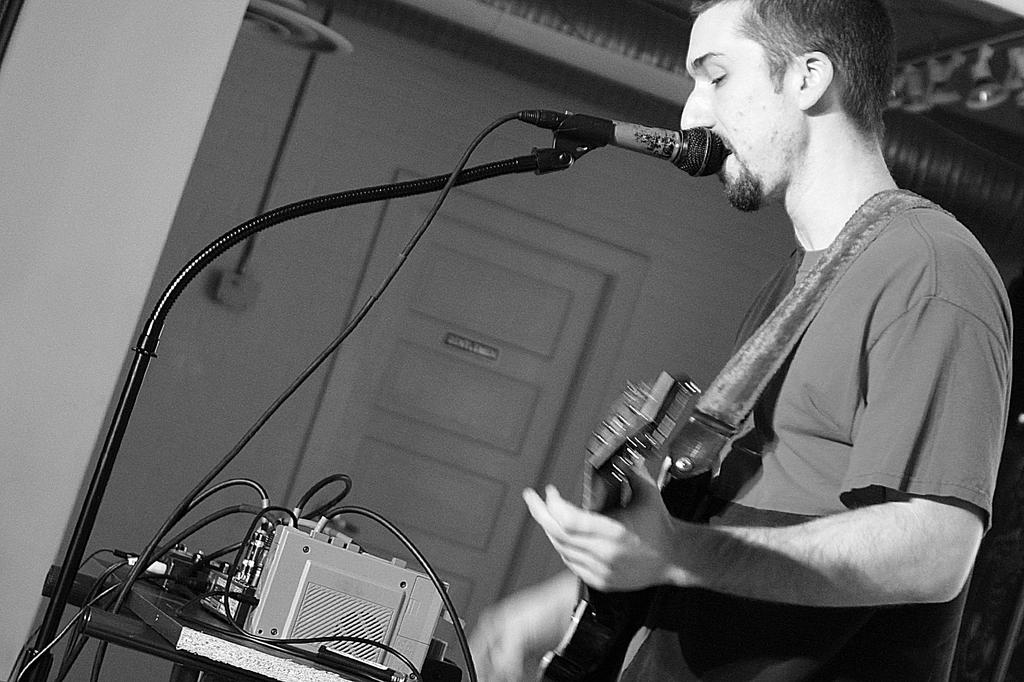What is the man in the image doing? The man is playing the guitar and singing on a mic. What instrument is the man holding in the image? The man is holding a guitar. What can be seen in the background of the image? There is a wall, a door, and a pipe in the background of the image. What type of bridge can be seen in the background of the image? There is no bridge present in the image; only a wall, a door, and a pipe can be seen in the background. 